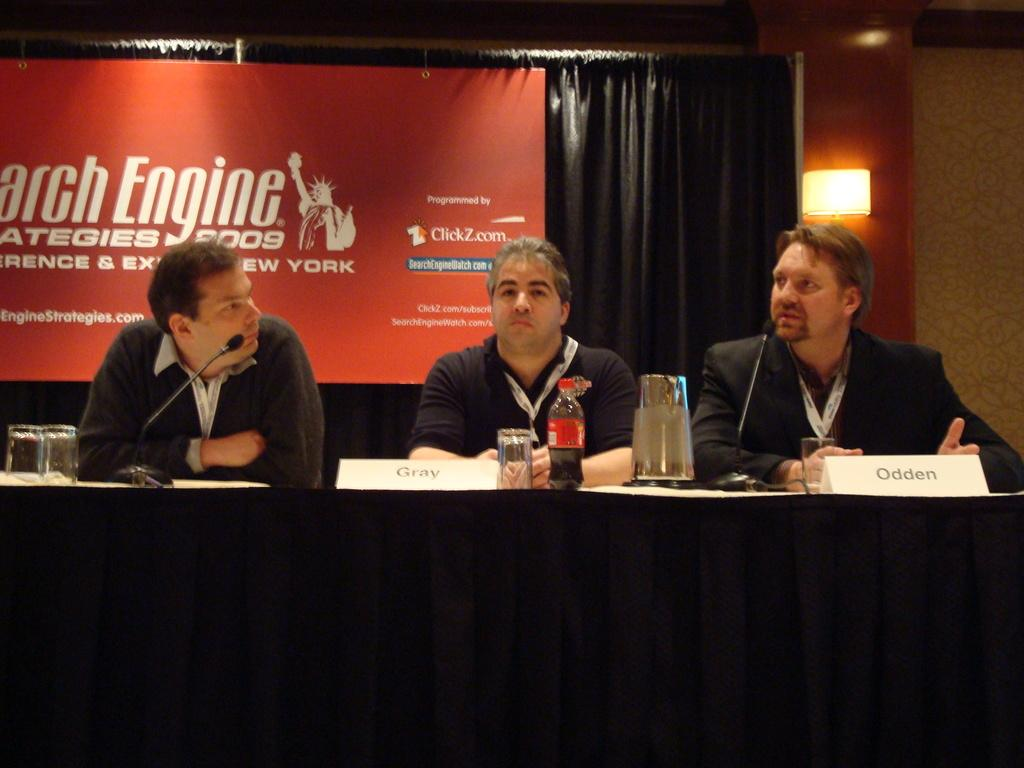Provide a one-sentence caption for the provided image. Three men are sitting at a table at the Search Engine strategies 2009 panel. 